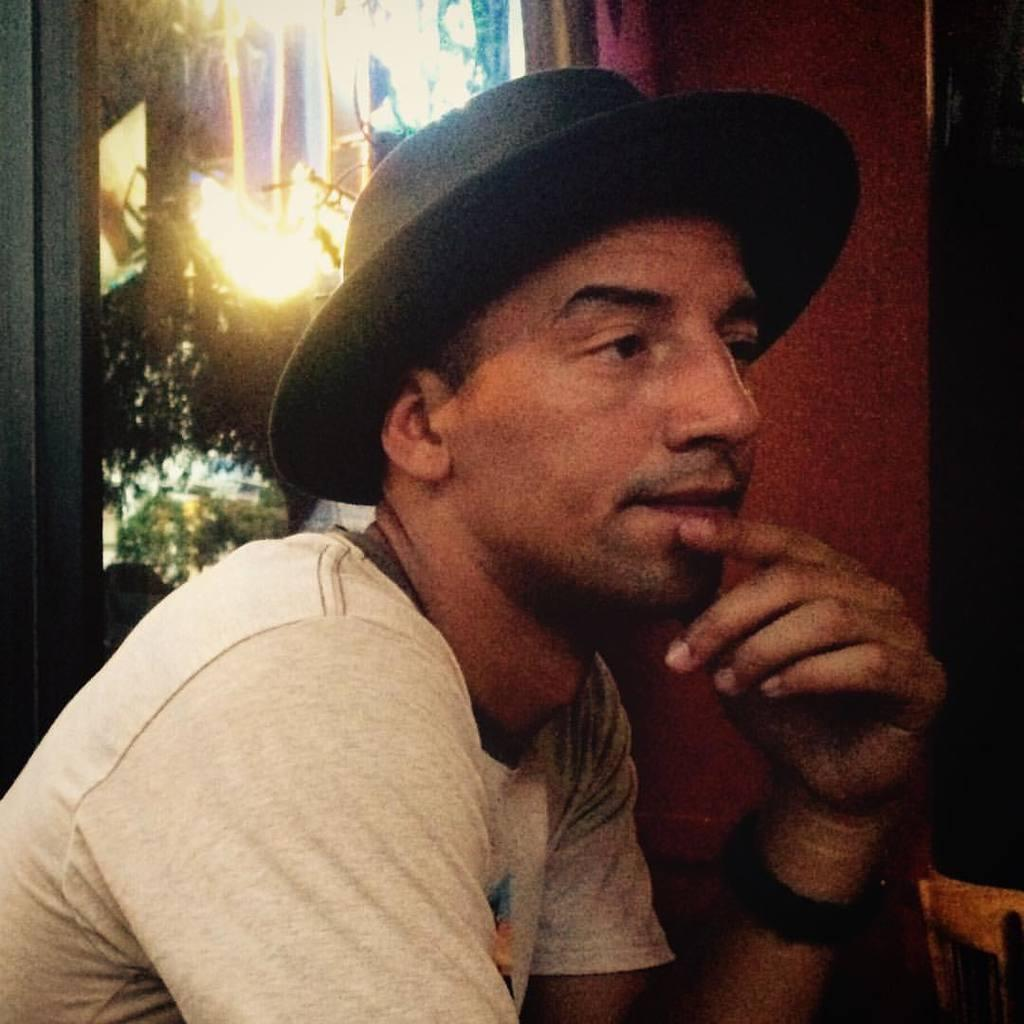Who is present in the image? There is a man in the image. What is the man wearing on his head? The man is wearing a hat. What color is the man's t-shirt? The man is wearing a white color t-shirt. What can be seen in the background of the image? There are lights and other objects in the background of the image. What type of jelly is the man eating in the image? There is no jelly present in the image, and the man is not eating anything. How does the man's tongue look like in the image? The man's tongue is not visible in the image, so it cannot be described. 